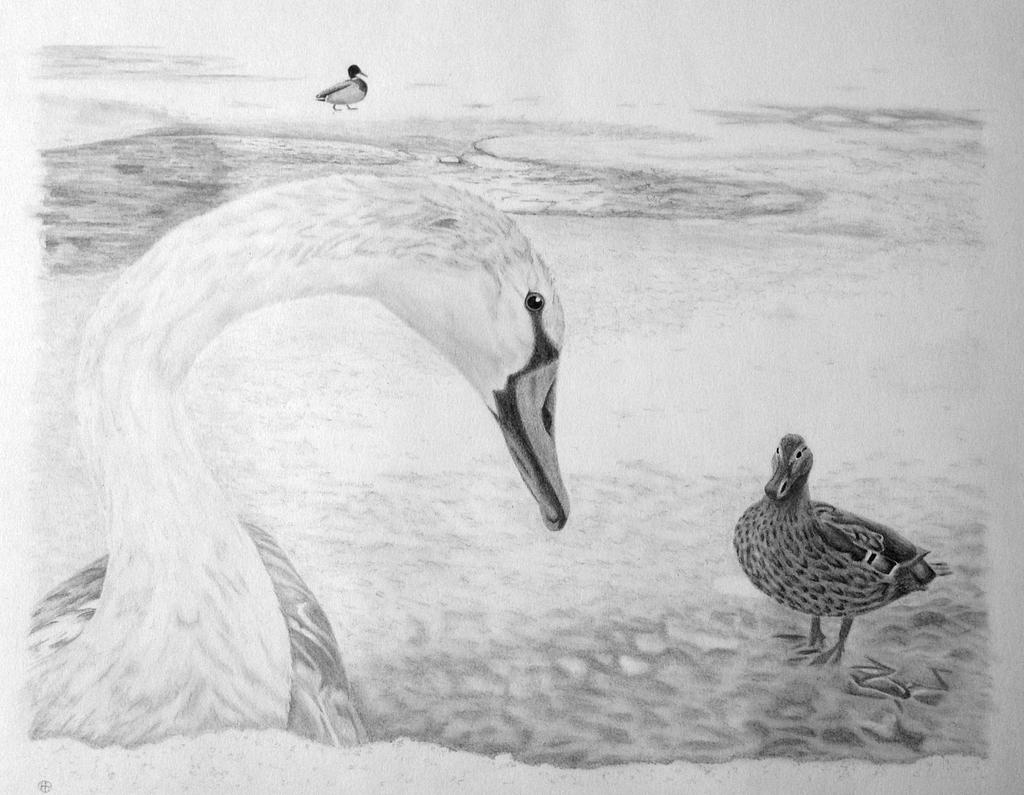What is depicted in the image? There is a drawing of a swan in the image. What other animals are present in the drawing? There are ducks in the drawing. What type of soda is being served in the drawing? There is no soda present in the drawing; it features a swan and ducks. What type of pan is being used to cook the swan and ducks in the drawing? There is no pan or cooking activity depicted in the drawing; it is a static image of a swan and ducks. 